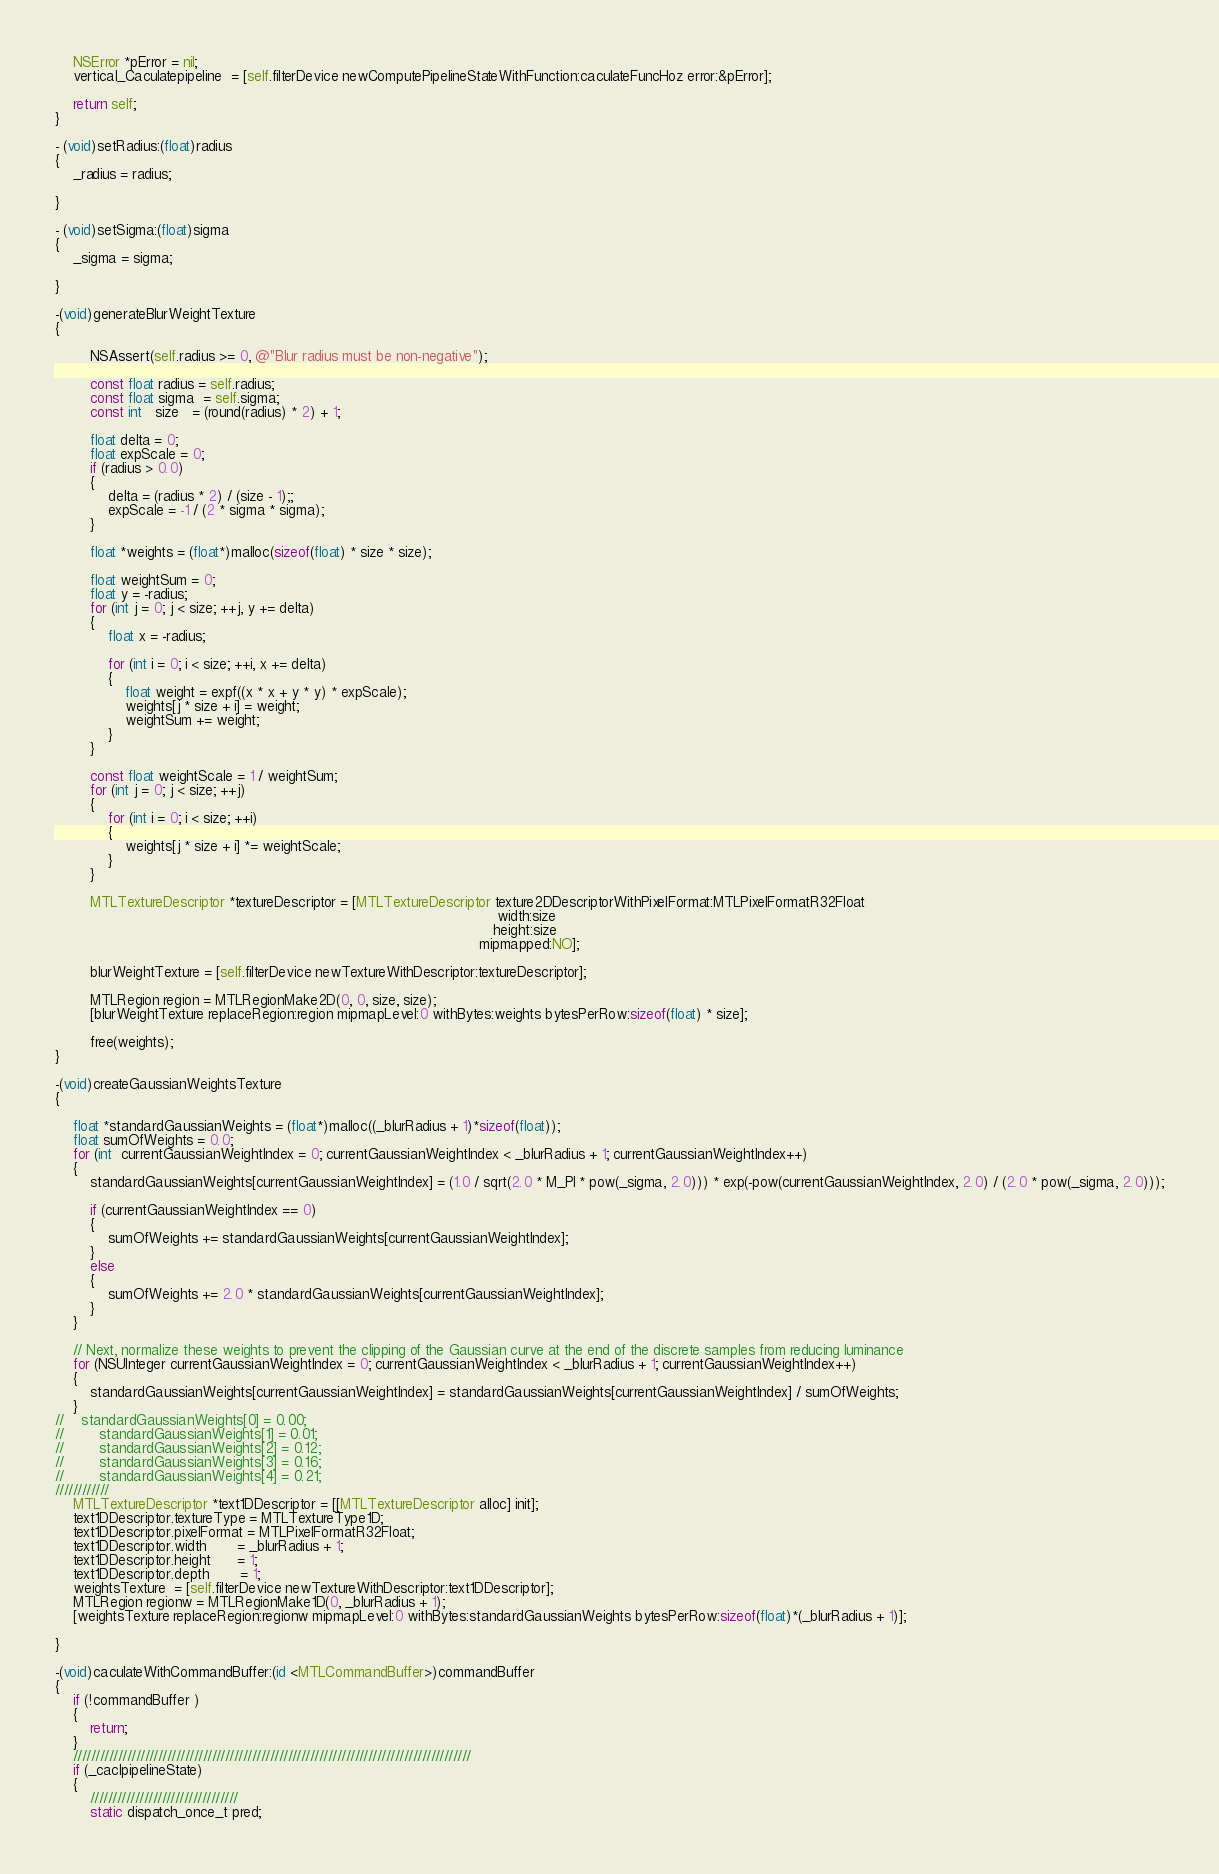<code> <loc_0><loc_0><loc_500><loc_500><_ObjectiveC_>    NSError *pError = nil;
    vertical_Caculatepipeline  = [self.filterDevice newComputePipelineStateWithFunction:caculateFuncHoz error:&pError];
    
    return self;
}

- (void)setRadius:(float)radius
{
    _radius = radius;
    
}

- (void)setSigma:(float)sigma
{
    _sigma = sigma;

}

-(void)generateBlurWeightTexture
{
   
        NSAssert(self.radius >= 0, @"Blur radius must be non-negative");
        
        const float radius = self.radius;
        const float sigma  = self.sigma;
        const int   size   = (round(radius) * 2) + 1;
        
        float delta = 0;
        float expScale = 0;
        if (radius > 0.0)
        {
            delta = (radius * 2) / (size - 1);;
            expScale = -1 / (2 * sigma * sigma);
        }
        
        float *weights = (float*)malloc(sizeof(float) * size * size);
        
        float weightSum = 0;
        float y = -radius;
        for (int j = 0; j < size; ++j, y += delta)
        {
            float x = -radius;
            
            for (int i = 0; i < size; ++i, x += delta)
            {
                float weight = expf((x * x + y * y) * expScale);
                weights[j * size + i] = weight;
                weightSum += weight;
            }
        }
        
        const float weightScale = 1 / weightSum;
        for (int j = 0; j < size; ++j)
        {
            for (int i = 0; i < size; ++i)
            {
                weights[j * size + i] *= weightScale;
            }
        }
        
        MTLTextureDescriptor *textureDescriptor = [MTLTextureDescriptor texture2DDescriptorWithPixelFormat:MTLPixelFormatR32Float
                                                                                                     width:size
                                                                                                    height:size
                                                                                                 mipmapped:NO];
        
        blurWeightTexture = [self.filterDevice newTextureWithDescriptor:textureDescriptor];
        
        MTLRegion region = MTLRegionMake2D(0, 0, size, size);
        [blurWeightTexture replaceRegion:region mipmapLevel:0 withBytes:weights bytesPerRow:sizeof(float) * size];
        
        free(weights);
}

-(void)createGaussianWeightsTexture
{
    
    float *standardGaussianWeights = (float*)malloc((_blurRadius + 1)*sizeof(float));
    float sumOfWeights = 0.0;
    for (int  currentGaussianWeightIndex = 0; currentGaussianWeightIndex < _blurRadius + 1; currentGaussianWeightIndex++)
    {
        standardGaussianWeights[currentGaussianWeightIndex] = (1.0 / sqrt(2.0 * M_PI * pow(_sigma, 2.0))) * exp(-pow(currentGaussianWeightIndex, 2.0) / (2.0 * pow(_sigma, 2.0)));
        
        if (currentGaussianWeightIndex == 0)
        {
            sumOfWeights += standardGaussianWeights[currentGaussianWeightIndex];
        }
        else
        {
            sumOfWeights += 2.0 * standardGaussianWeights[currentGaussianWeightIndex];
        }
    }
    
    // Next, normalize these weights to prevent the clipping of the Gaussian curve at the end of the discrete samples from reducing luminance
    for (NSUInteger currentGaussianWeightIndex = 0; currentGaussianWeightIndex < _blurRadius + 1; currentGaussianWeightIndex++)
    {
        standardGaussianWeights[currentGaussianWeightIndex] = standardGaussianWeights[currentGaussianWeightIndex] / sumOfWeights;
    }
//    standardGaussianWeights[0] = 0.00;
//        standardGaussianWeights[1] = 0.01;
//        standardGaussianWeights[2] = 0.12;
//        standardGaussianWeights[3] = 0.16;
//        standardGaussianWeights[4] = 0.21;
////////////
    MTLTextureDescriptor *text1DDescriptor = [[MTLTextureDescriptor alloc] init];
    text1DDescriptor.textureType = MTLTextureType1D;
    text1DDescriptor.pixelFormat = MTLPixelFormatR32Float;
    text1DDescriptor.width       = _blurRadius + 1;
    text1DDescriptor.height      = 1;
    text1DDescriptor.depth       = 1;
    weightsTexture  = [self.filterDevice newTextureWithDescriptor:text1DDescriptor];
    MTLRegion regionw = MTLRegionMake1D(0, _blurRadius + 1);
    [weightsTexture replaceRegion:regionw mipmapLevel:0 withBytes:standardGaussianWeights bytesPerRow:sizeof(float)*(_blurRadius + 1)];
    
}

-(void)caculateWithCommandBuffer:(id <MTLCommandBuffer>)commandBuffer
{
    if (!commandBuffer )
    {
        return;
    }
    /////////////////////////////////////////////////////////////////////////////////////////
    if (_caclpipelineState)
    {
        /////////////////////////////////
        static dispatch_once_t pred;</code> 